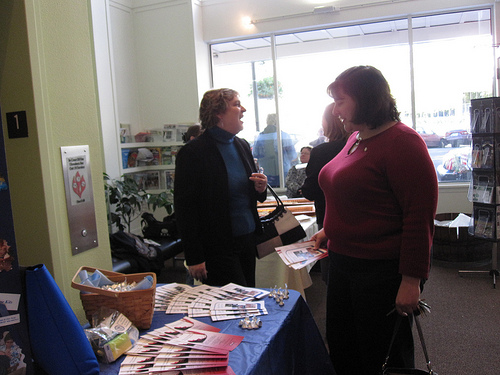<image>
Can you confirm if the papers is to the right of the basket? Yes. From this viewpoint, the papers is positioned to the right side relative to the basket. Is the lady in front of the table? Yes. The lady is positioned in front of the table, appearing closer to the camera viewpoint. 